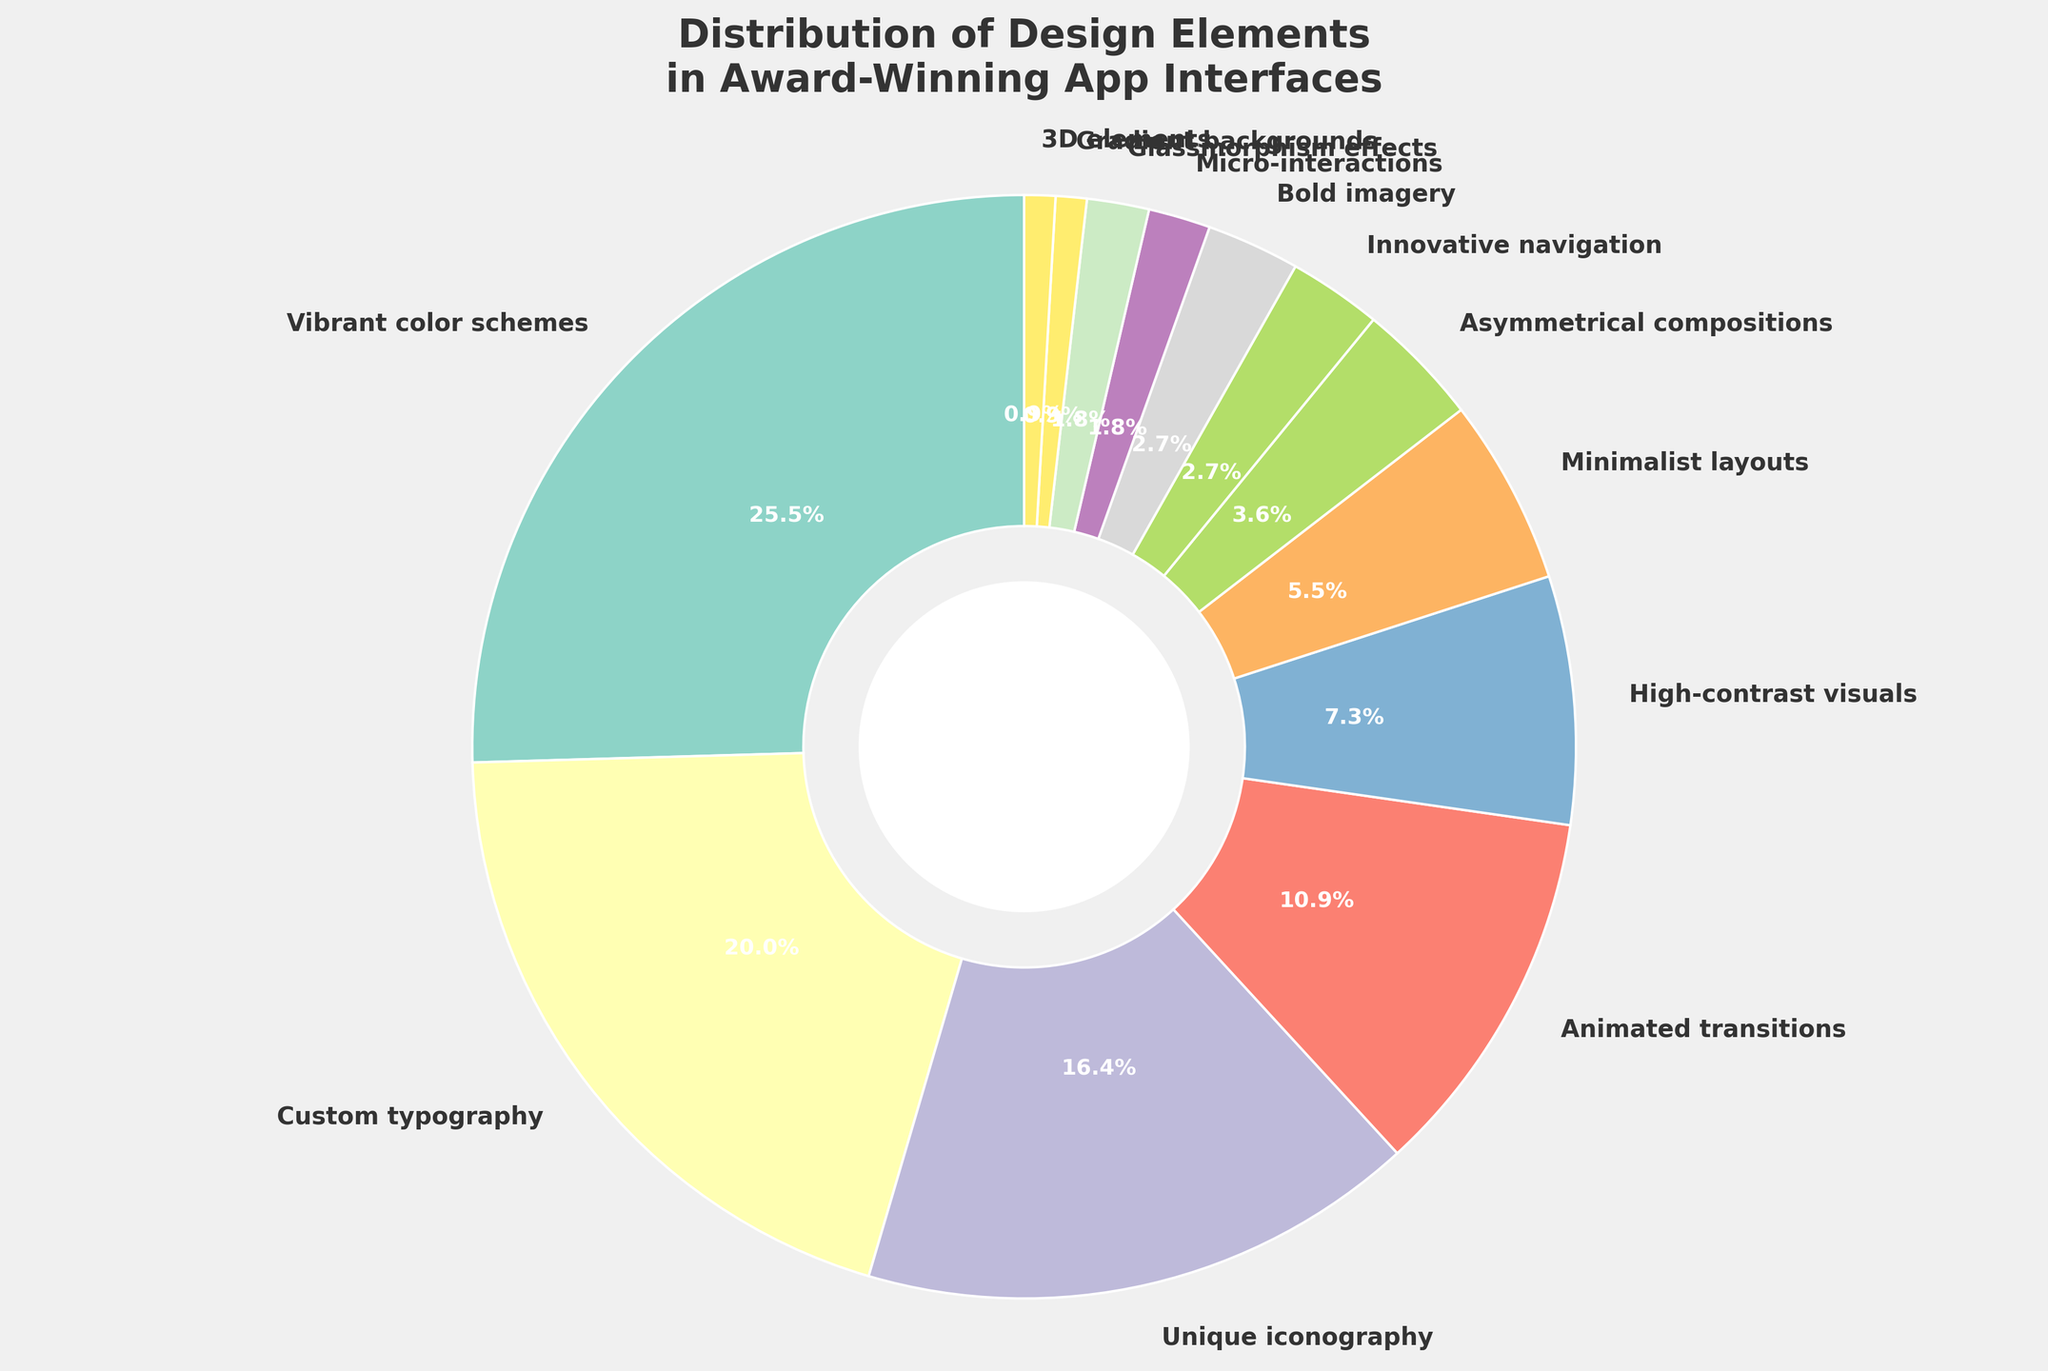What's the design element with the highest percentage? Look at the pie chart and identify which segment represents the largest percentage. The segment labeled "Vibrant color schemes" has the highest percentage (28%).
Answer: Vibrant color schemes What is the total percentage of Custom typography and Unique iconography combined? Identify the percentages for Custom typography (22%) and Unique iconography (18%), then add them together: 22% + 18% = 40%.
Answer: 40% Which design element has the smallest representation and what is its percentage? Look at the pie chart and identify the smallest segment. The segment labeled as "Gradient backgrounds" and "3D elements" both have the smallest percentages at 1%. Therefore, "Gradient backgrounds" and "3D elements" are both the correct answers.
Answer: Gradient backgrounds and 3D elements, 1% How much more percentage does Vibrant color schemes have compared to Minimalist layouts? Identify the percentages for Vibrant color schemes (28%) and Minimalist layouts (6%), then calculate the difference: 28% - 6% = 22%.
Answer: 22% What is the combined percentage of design elements that have less than 5% representation? Identify the elements with percentages less than 5%: Asymmetrical compositions (4%), Innovative navigation (3%), Bold imagery (3%), Micro-interactions (2%), Glassmorphism effects (2%), Gradient backgrounds (1%), and 3D elements (1%). Add these percentages: 4% + 3% + 3% + 2% + 2% + 1% + 1% = 16%.
Answer: 16% What are the second and third most common design elements and their percentages? Identify the elements with the highest percentages and then find the second and third highest after Vibrant color schemes (28%): Custom typography (22%) and Unique iconography (18%).
Answer: Custom typography 22%, Unique iconography 18% Is the percentage of Animated transitions greater than the combined percentage of Micro-interactions and Glassmorphism effects? Identify the percentages for Animated transitions (12%), Micro-interactions (2%), and Glassmorphism effects (2%). Sum the latter two: 2% + 2% = 4%. Compare: 12% is greater than 4%.
Answer: Yes Which visual segment in the pie chart uses a color located towards the center of the color wheel and what element does it represent? Observe the colors used in the pie chart; the segment with a color towards the center of the color wheel (i.e., balanced, moderate) represents "Unique iconography" at 18%.
Answer: Unique iconography What is the difference in percentage between Custom typography and Asymmetrical compositions? Identify the percentages for Custom typography (22%) and Asymmetrical compositions (4%). Calculate the difference: 22% - 4% = 18%.
Answer: 18% 